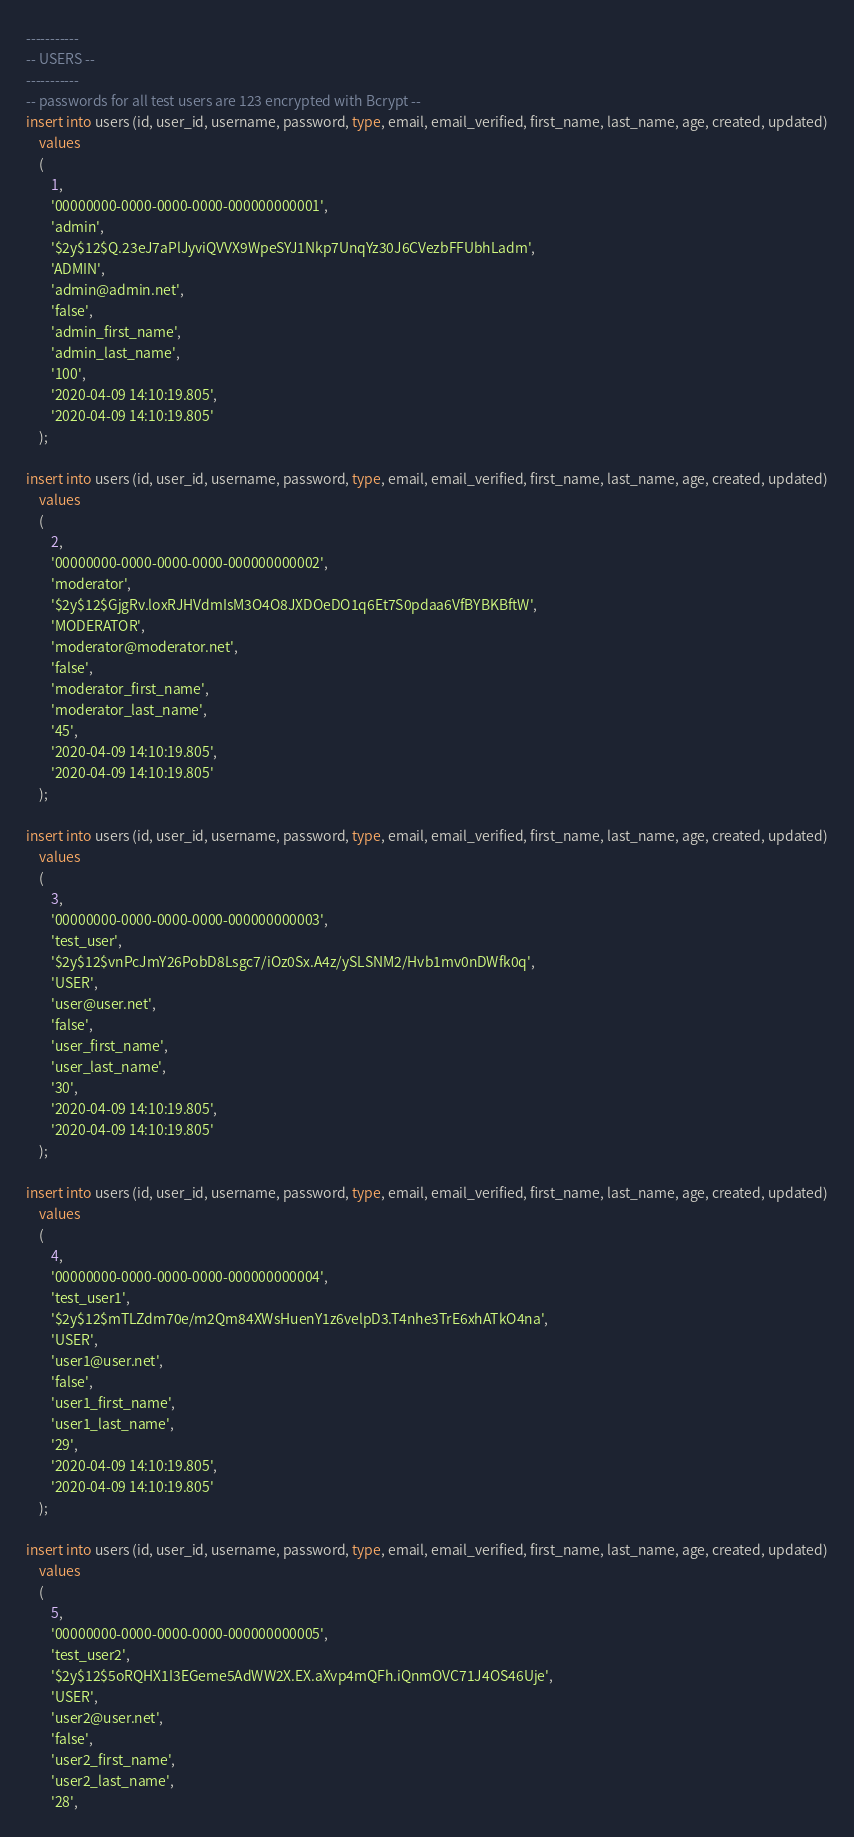Convert code to text. <code><loc_0><loc_0><loc_500><loc_500><_SQL_>-----------
-- USERS --
-----------
-- passwords for all test users are 123 encrypted with Bcrypt --
insert into users (id, user_id, username, password, type, email, email_verified, first_name, last_name, age, created, updated)
    values
    (
        1,
        '00000000-0000-0000-0000-000000000001',
        'admin',
        '$2y$12$Q.23eJ7aPlJyviQVVX9WpeSYJ1Nkp7UnqYz30J6CVezbFFUbhLadm',
        'ADMIN',
        'admin@admin.net',
        'false',
        'admin_first_name',
        'admin_last_name',
        '100',
        '2020-04-09 14:10:19.805',
        '2020-04-09 14:10:19.805'
    );

insert into users (id, user_id, username, password, type, email, email_verified, first_name, last_name, age, created, updated)
    values
    (
        2,
        '00000000-0000-0000-0000-000000000002',
        'moderator',
        '$2y$12$GjgRv.loxRJHVdmIsM3O4O8JXDOeDO1q6Et7S0pdaa6VfBYBKBftW',
        'MODERATOR',
        'moderator@moderator.net',
        'false',
        'moderator_first_name',
        'moderator_last_name',
        '45',
        '2020-04-09 14:10:19.805',
        '2020-04-09 14:10:19.805'
    );

insert into users (id, user_id, username, password, type, email, email_verified, first_name, last_name, age, created, updated)
    values
    (
        3,
        '00000000-0000-0000-0000-000000000003',
        'test_user',
        '$2y$12$vnPcJmY26PobD8Lsgc7/iOz0Sx.A4z/ySLSNM2/Hvb1mv0nDWfk0q',
        'USER',
        'user@user.net',
        'false',
        'user_first_name',
        'user_last_name',
        '30',
        '2020-04-09 14:10:19.805',
        '2020-04-09 14:10:19.805'
    );

insert into users (id, user_id, username, password, type, email, email_verified, first_name, last_name, age, created, updated)
    values
    (
        4,
        '00000000-0000-0000-0000-000000000004',
        'test_user1',
        '$2y$12$mTLZdm70e/m2Qm84XWsHuenY1z6velpD3.T4nhe3TrE6xhATkO4na',
        'USER',
        'user1@user.net',
        'false',
        'user1_first_name',
        'user1_last_name',
        '29',
        '2020-04-09 14:10:19.805',
        '2020-04-09 14:10:19.805'
    );

insert into users (id, user_id, username, password, type, email, email_verified, first_name, last_name, age, created, updated)
    values
    (
        5,
        '00000000-0000-0000-0000-000000000005',
        'test_user2',
        '$2y$12$5oRQHX1I3EGeme5AdWW2X.EX.aXvp4mQFh.iQnmOVC71J4OS46Uje',
        'USER',
        'user2@user.net',
        'false',
        'user2_first_name',
        'user2_last_name',
        '28',</code> 